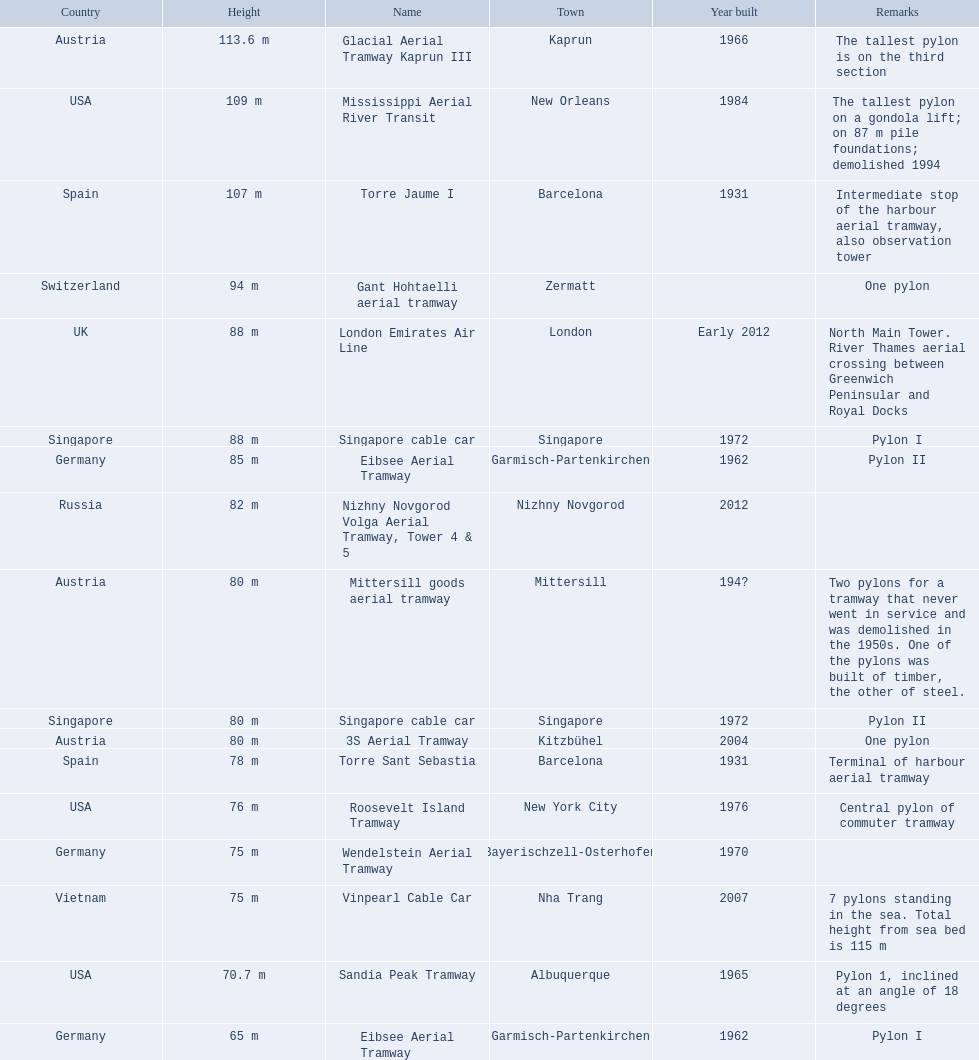Write the full table. {'header': ['Country', 'Height', 'Name', 'Town', 'Year built', 'Remarks'], 'rows': [['Austria', '113.6 m', 'Glacial Aerial Tramway Kaprun III', 'Kaprun', '1966', 'The tallest pylon is on the third section'], ['USA', '109 m', 'Mississippi Aerial River Transit', 'New Orleans', '1984', 'The tallest pylon on a gondola lift; on 87 m pile foundations; demolished 1994'], ['Spain', '107 m', 'Torre Jaume I', 'Barcelona', '1931', 'Intermediate stop of the harbour aerial tramway, also observation tower'], ['Switzerland', '94 m', 'Gant Hohtaelli aerial tramway', 'Zermatt', '', 'One pylon'], ['UK', '88 m', 'London Emirates Air Line', 'London', 'Early 2012', 'North Main Tower. River Thames aerial crossing between Greenwich Peninsular and Royal Docks'], ['Singapore', '88 m', 'Singapore cable car', 'Singapore', '1972', 'Pylon I'], ['Germany', '85 m', 'Eibsee Aerial Tramway', 'Garmisch-Partenkirchen', '1962', 'Pylon II'], ['Russia', '82 m', 'Nizhny Novgorod Volga Aerial Tramway, Tower 4 & 5', 'Nizhny Novgorod', '2012', ''], ['Austria', '80 m', 'Mittersill goods aerial tramway', 'Mittersill', '194?', 'Two pylons for a tramway that never went in service and was demolished in the 1950s. One of the pylons was built of timber, the other of steel.'], ['Singapore', '80 m', 'Singapore cable car', 'Singapore', '1972', 'Pylon II'], ['Austria', '80 m', '3S Aerial Tramway', 'Kitzbühel', '2004', 'One pylon'], ['Spain', '78 m', 'Torre Sant Sebastia', 'Barcelona', '1931', 'Terminal of harbour aerial tramway'], ['USA', '76 m', 'Roosevelt Island Tramway', 'New York City', '1976', 'Central pylon of commuter tramway'], ['Germany', '75 m', 'Wendelstein Aerial Tramway', 'Bayerischzell-Osterhofen', '1970', ''], ['Vietnam', '75 m', 'Vinpearl Cable Car', 'Nha Trang', '2007', '7 pylons standing in the sea. Total height from sea bed is 115 m'], ['USA', '70.7 m', 'Sandia Peak Tramway', 'Albuquerque', '1965', 'Pylon 1, inclined at an angle of 18 degrees'], ['Germany', '65 m', 'Eibsee Aerial Tramway', 'Garmisch-Partenkirchen', '1962', 'Pylon I']]} How many aerial lift pylon's on the list are located in the usa? Mississippi Aerial River Transit, Roosevelt Island Tramway, Sandia Peak Tramway. Of the pylon's located in the usa how many were built after 1970? Mississippi Aerial River Transit, Roosevelt Island Tramway. Of the pylon's built after 1970 which is the tallest pylon on a gondola lift? Mississippi Aerial River Transit. How many meters is the tallest pylon on a gondola lift? 109 m. 